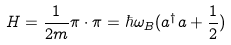<formula> <loc_0><loc_0><loc_500><loc_500>H = \frac { 1 } { 2 m } \pi \cdot \pi = \hbar { \omega } _ { B } ( a ^ { \dagger } a + \frac { 1 } { 2 } )</formula> 